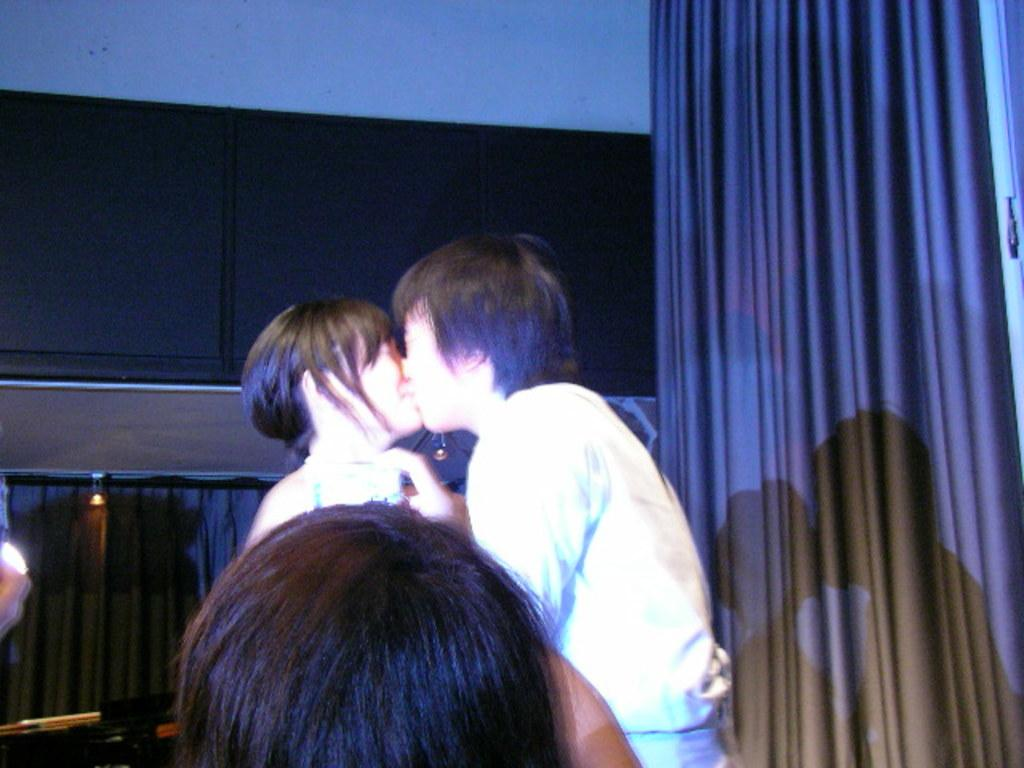What are the two persons in the image doing? The two persons are kissing each other in the image. Can you describe the person in front of them? There is a person in front of them, but no specific details are provided about this person. What is visible in the background of the image? There is a wall in the background of the image. What is on the left side of the image? There is a curtain on the left side of the image. What type of cough can be heard from the person in the image? There is no indication of a cough or any sound in the image, as it is a still photograph. What color is the yarn used to make the coach in the image? There is no coach or yarn present in the image. 